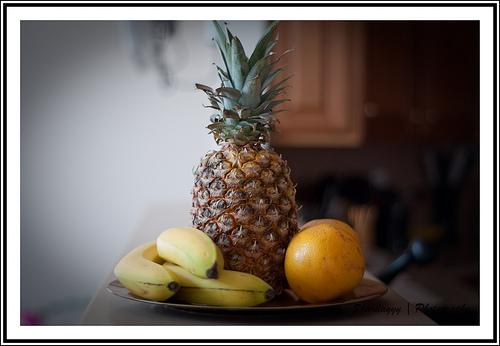With which fruit would be most connected to Costa Rica? pineapple 